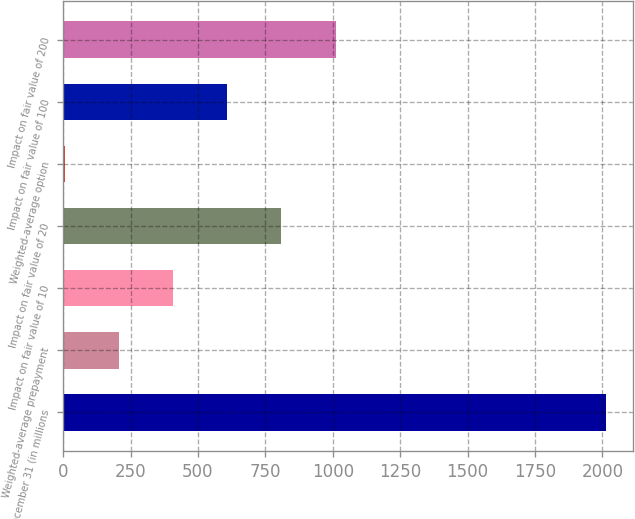<chart> <loc_0><loc_0><loc_500><loc_500><bar_chart><fcel>December 31 (in millions<fcel>Weighted-average prepayment<fcel>Impact on fair value of 10<fcel>Impact on fair value of 20<fcel>Weighted-average option<fcel>Impact on fair value of 100<fcel>Impact on fair value of 200<nl><fcel>2013<fcel>208.29<fcel>408.81<fcel>809.85<fcel>7.77<fcel>609.33<fcel>1010.37<nl></chart> 